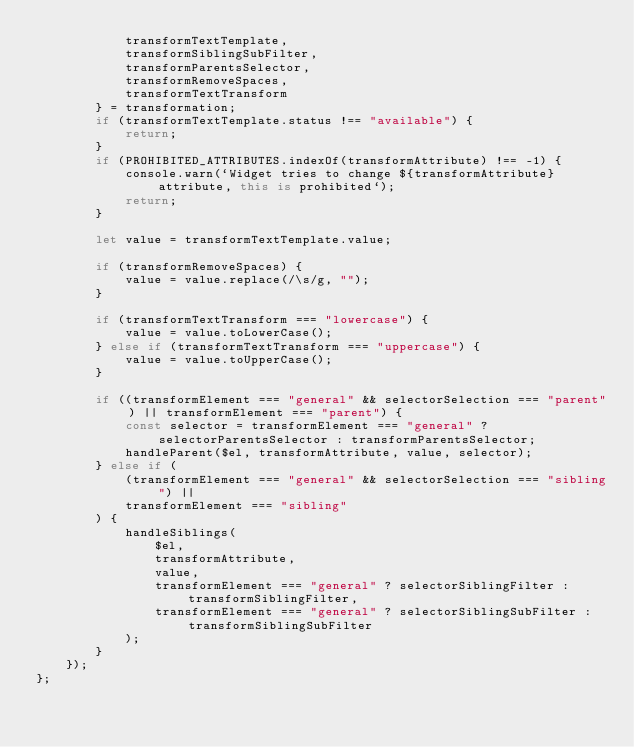<code> <loc_0><loc_0><loc_500><loc_500><_TypeScript_>            transformTextTemplate,
            transformSiblingSubFilter,
            transformParentsSelector,
            transformRemoveSpaces,
            transformTextTransform
        } = transformation;
        if (transformTextTemplate.status !== "available") {
            return;
        }
        if (PROHIBITED_ATTRIBUTES.indexOf(transformAttribute) !== -1) {
            console.warn(`Widget tries to change ${transformAttribute} attribute, this is prohibited`);
            return;
        }

        let value = transformTextTemplate.value;

        if (transformRemoveSpaces) {
            value = value.replace(/\s/g, "");
        }

        if (transformTextTransform === "lowercase") {
            value = value.toLowerCase();
        } else if (transformTextTransform === "uppercase") {
            value = value.toUpperCase();
        }

        if ((transformElement === "general" && selectorSelection === "parent") || transformElement === "parent") {
            const selector = transformElement === "general" ? selectorParentsSelector : transformParentsSelector;
            handleParent($el, transformAttribute, value, selector);
        } else if (
            (transformElement === "general" && selectorSelection === "sibling") ||
            transformElement === "sibling"
        ) {
            handleSiblings(
                $el,
                transformAttribute,
                value,
                transformElement === "general" ? selectorSiblingFilter : transformSiblingFilter,
                transformElement === "general" ? selectorSiblingSubFilter : transformSiblingSubFilter
            );
        }
    });
};
</code> 